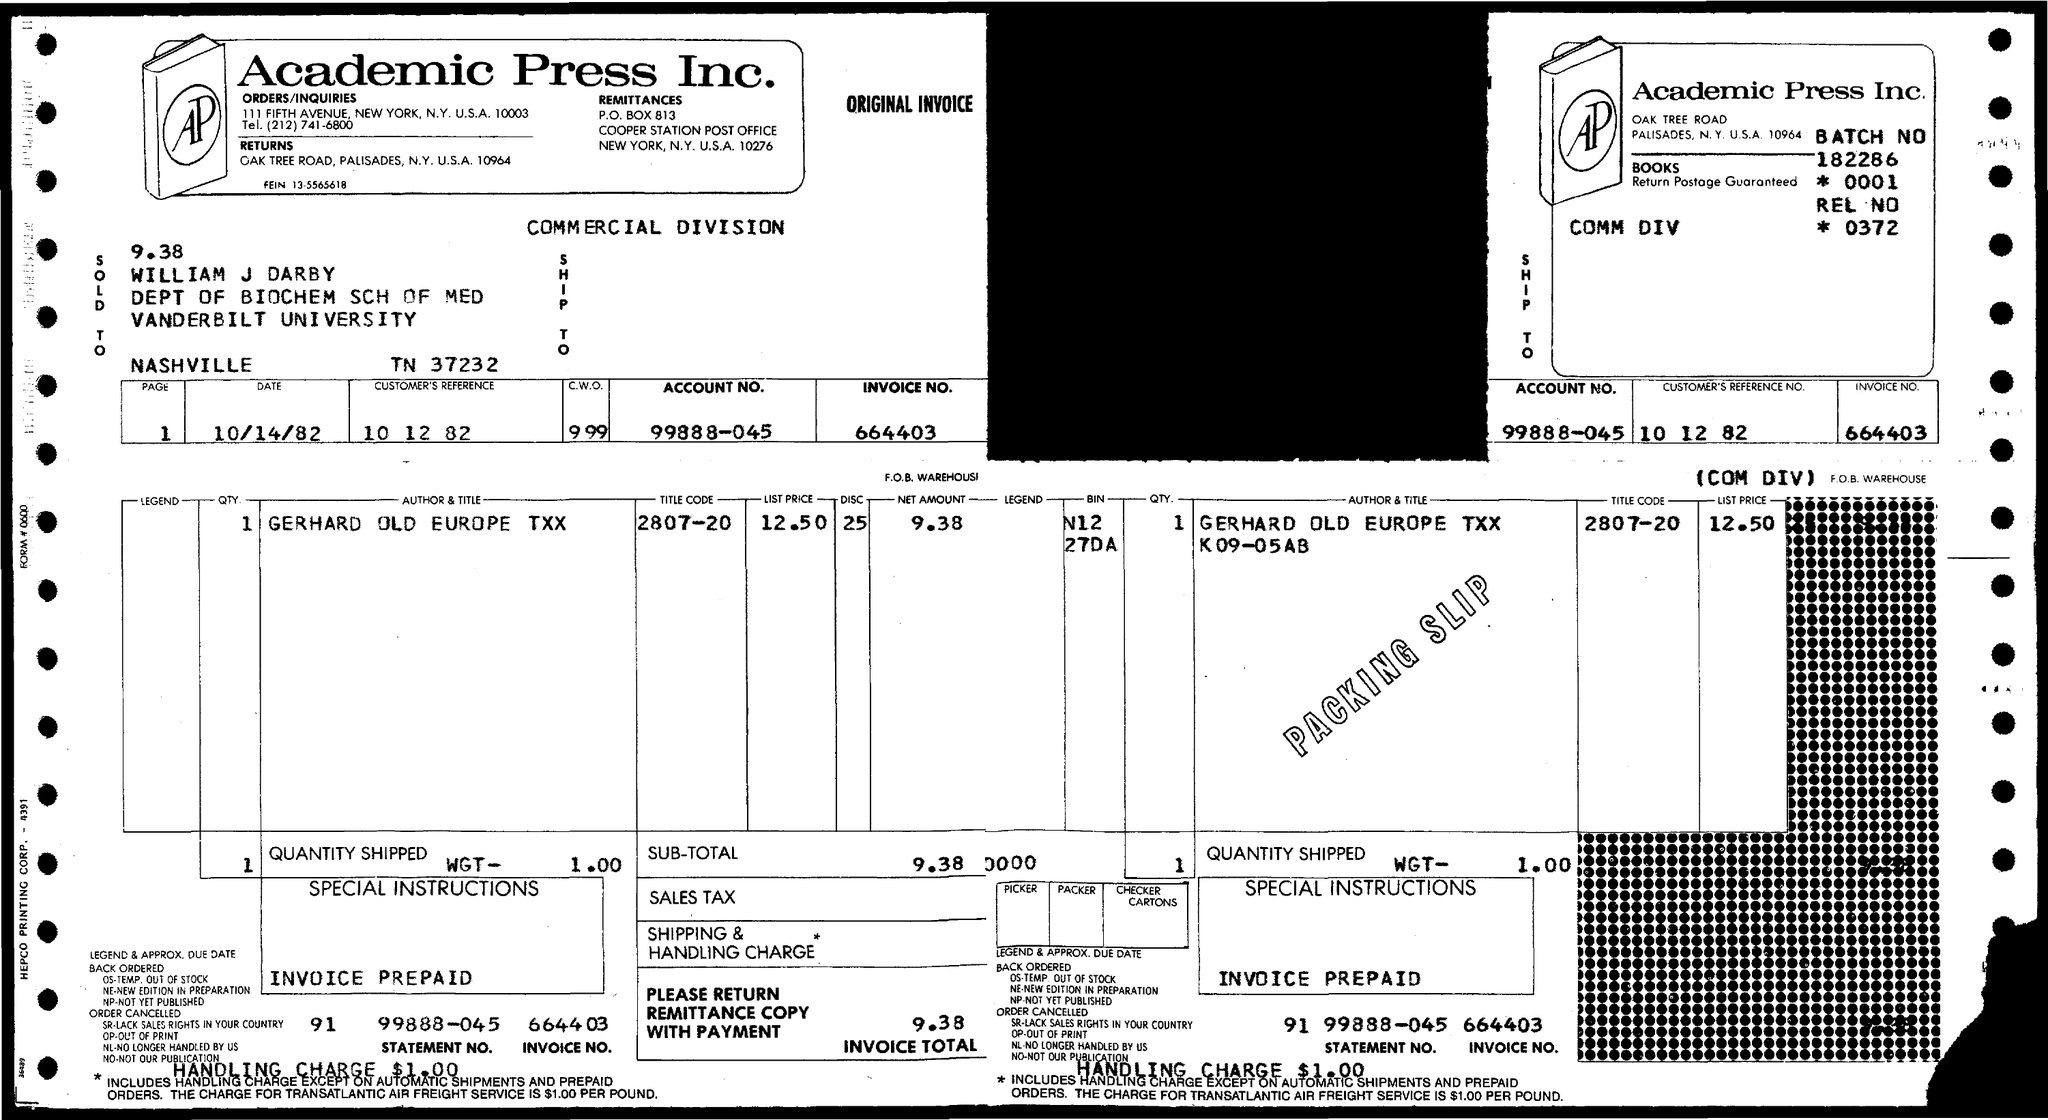What is the Company Name ?
Provide a succinct answer. Academic Press Inc. What is the Account no ?
Keep it short and to the point. 99888-045. What is the Invoice Number ?
Ensure brevity in your answer.  664403. How much invoice total ?
Give a very brief answer. 9.38. 